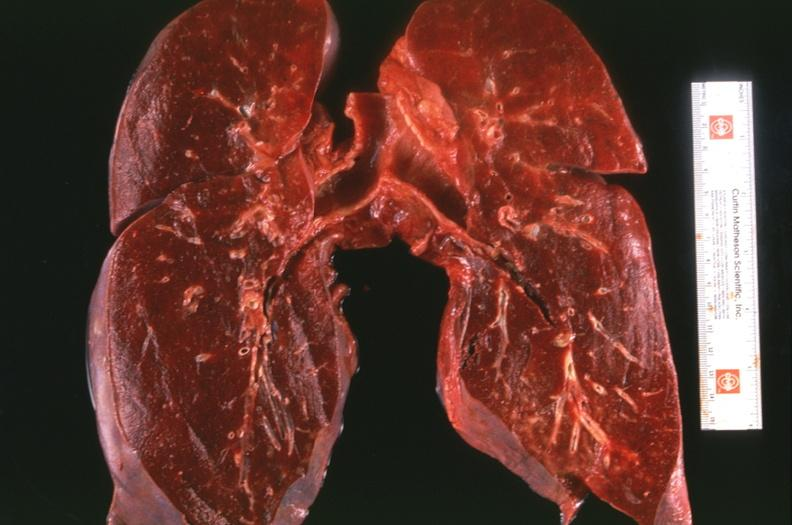s testicle present?
Answer the question using a single word or phrase. No 